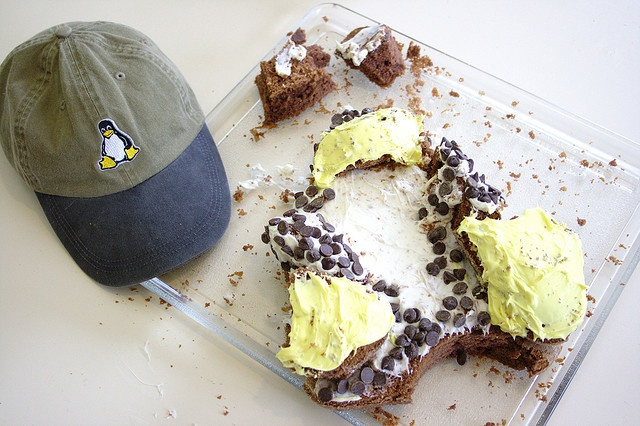Describe the objects in this image and their specific colors. I can see dining table in lightgray, darkgray, beige, gray, and black tones and cake in lightgray, ivory, khaki, black, and gray tones in this image. 